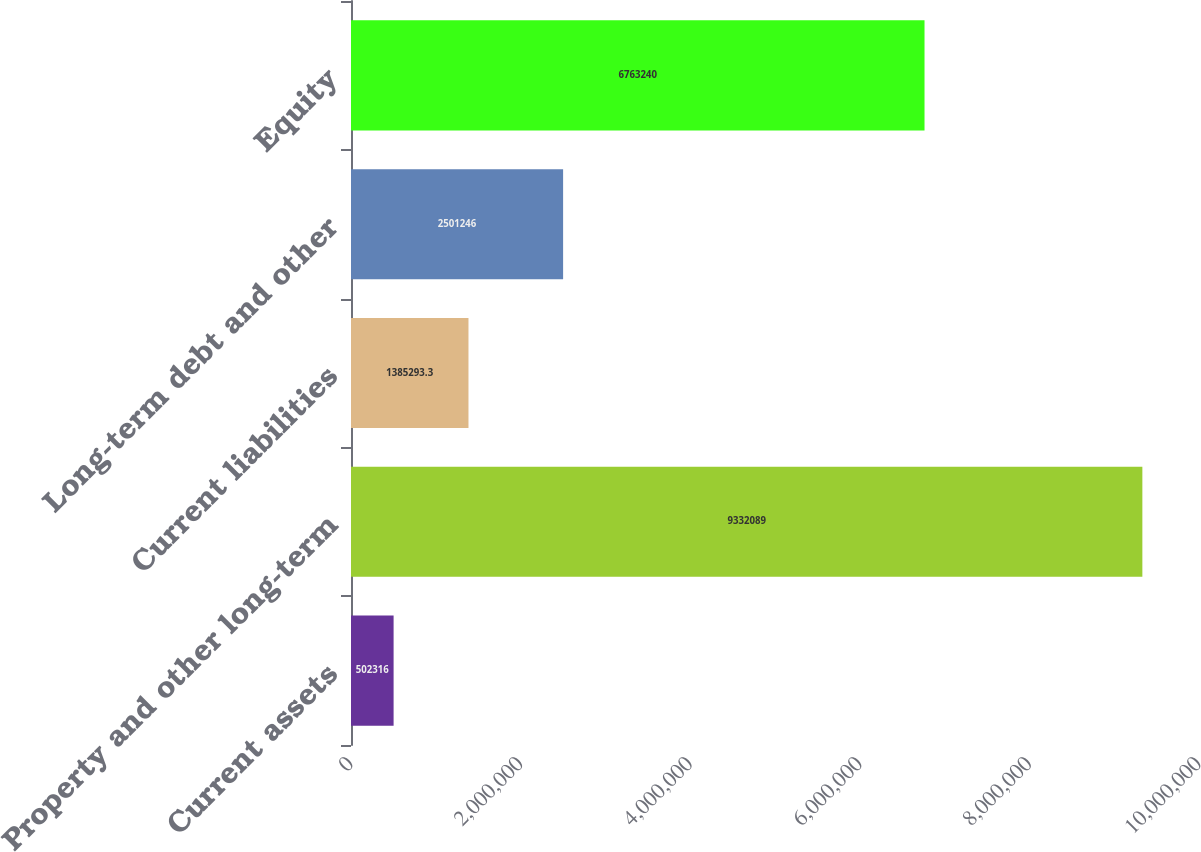<chart> <loc_0><loc_0><loc_500><loc_500><bar_chart><fcel>Current assets<fcel>Property and other long-term<fcel>Current liabilities<fcel>Long-term debt and other<fcel>Equity<nl><fcel>502316<fcel>9.33209e+06<fcel>1.38529e+06<fcel>2.50125e+06<fcel>6.76324e+06<nl></chart> 